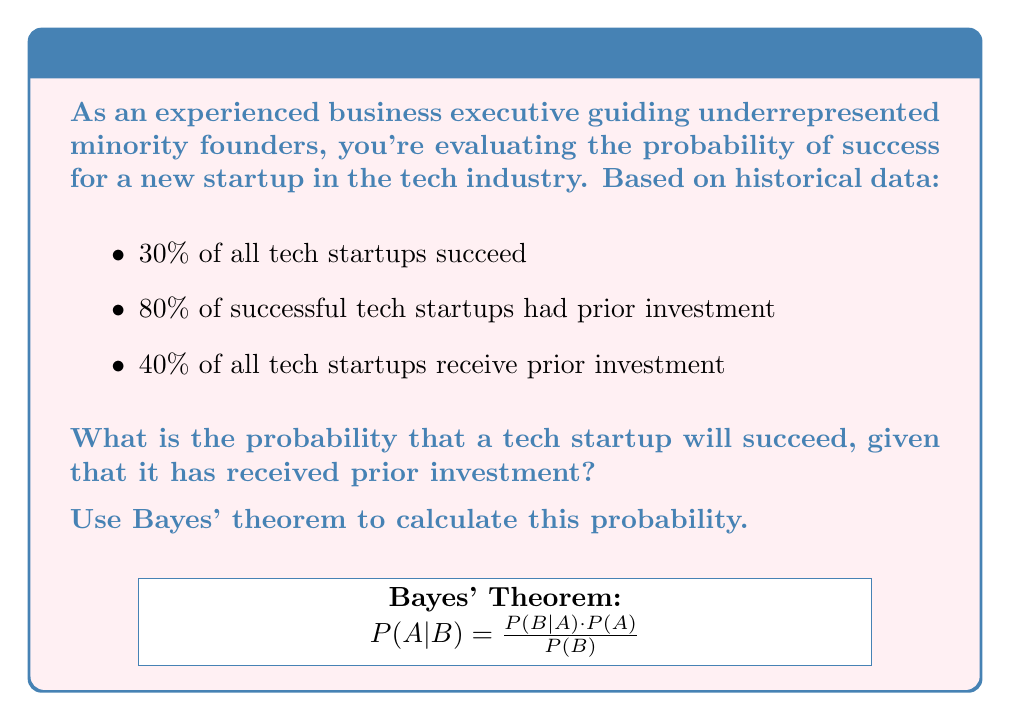Teach me how to tackle this problem. Let's approach this step-by-step using Bayes' theorem:

1) Define our events:
   S: Startup succeeds
   I: Startup receives prior investment

2) Given probabilities:
   P(S) = 0.30 (30% of all tech startups succeed)
   P(I|S) = 0.80 (80% of successful tech startups had prior investment)
   P(I) = 0.40 (40% of all tech startups receive prior investment)

3) We want to find P(S|I), which is the probability of success given prior investment.

4) Bayes' theorem states:

   $$P(S|I) = \frac{P(I|S) \cdot P(S)}{P(I)}$$

5) Substitute the known values:

   $$P(S|I) = \frac{0.80 \cdot 0.30}{0.40}$$

6) Calculate:

   $$P(S|I) = \frac{0.24}{0.40} = 0.60$$

7) Convert to percentage:
   0.60 * 100 = 60%

Therefore, the probability that a tech startup will succeed, given that it has received prior investment, is 60%.
Answer: 60% 